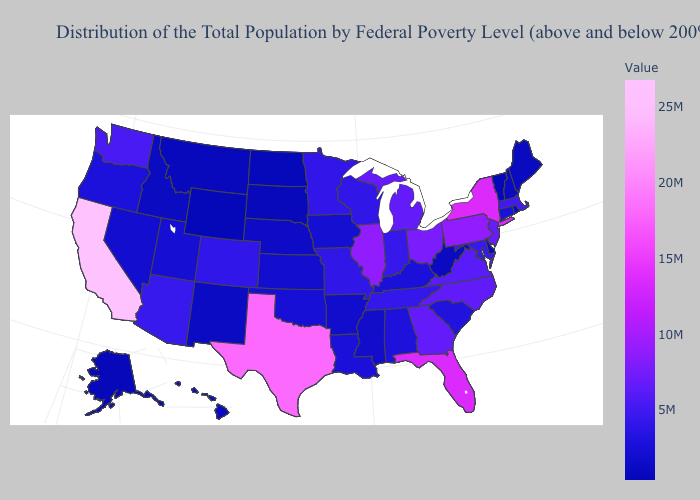Among the states that border Mississippi , which have the lowest value?
Concise answer only. Arkansas. Which states have the highest value in the USA?
Quick response, please. California. Does Wyoming have the lowest value in the USA?
Short answer required. Yes. Does Wyoming have the lowest value in the USA?
Be succinct. Yes. Among the states that border Idaho , does Montana have the highest value?
Quick response, please. No. 